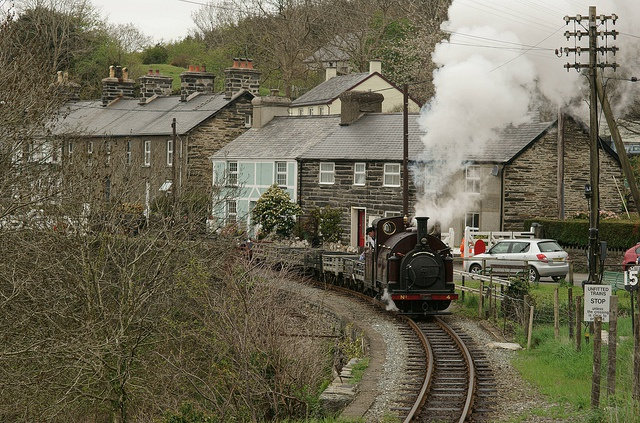Describe the objects in this image and their specific colors. I can see train in lightgray, black, gray, and maroon tones, car in lightgray, gray, darkgray, and black tones, car in lightgray, brown, black, gray, and maroon tones, people in lightgray, black, gray, darkgray, and maroon tones, and people in lightgray, gray, black, and darkgray tones in this image. 